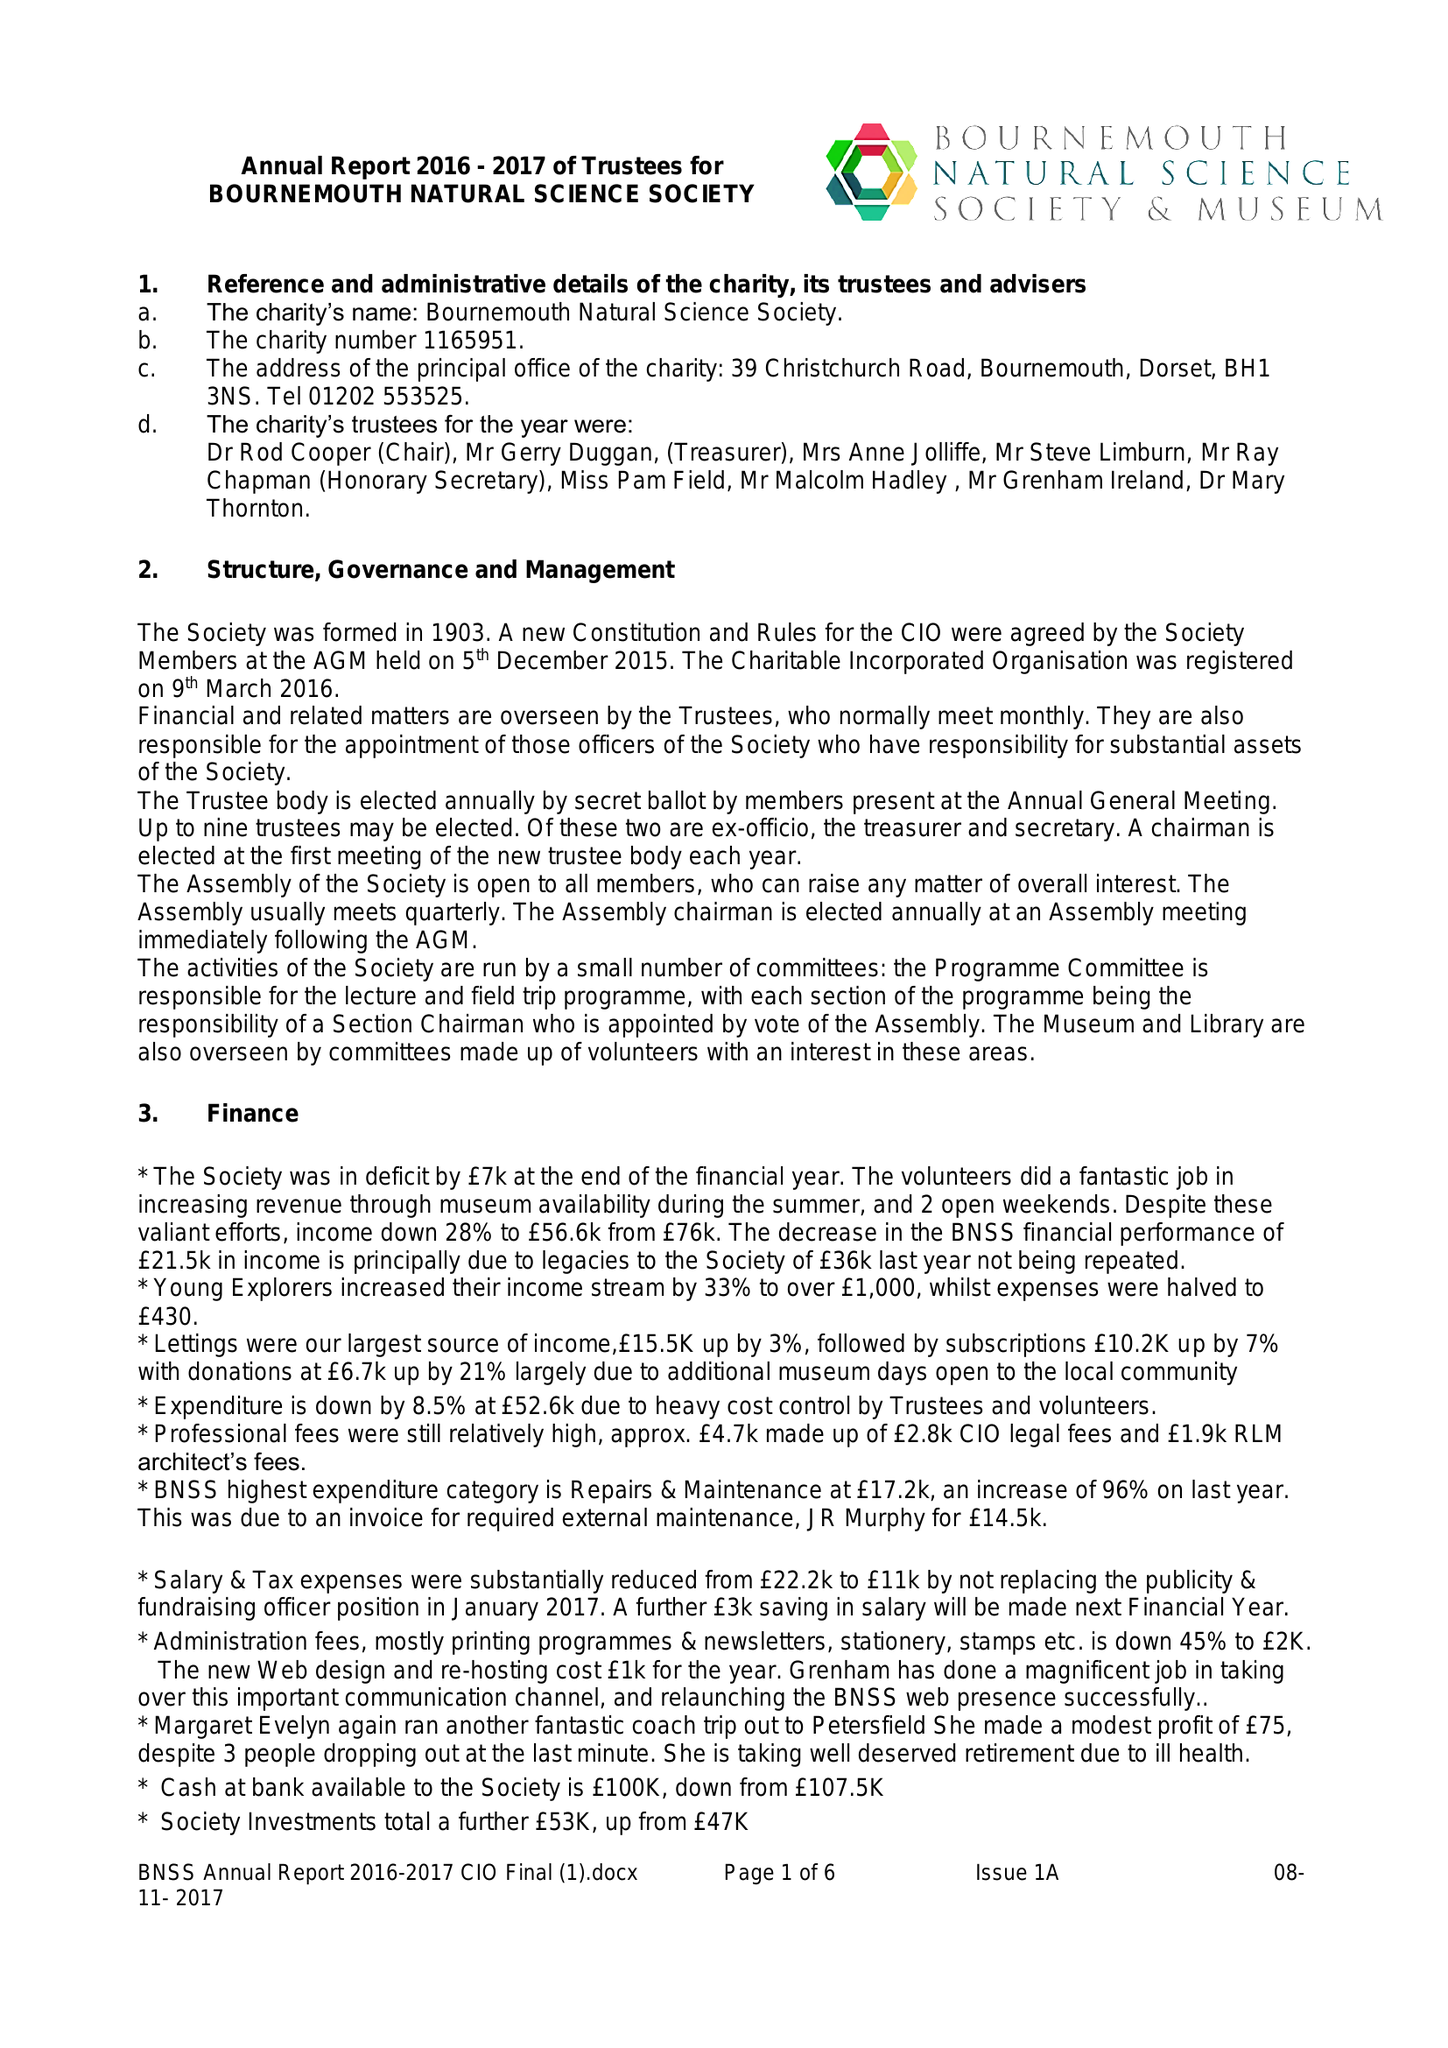What is the value for the address__postcode?
Answer the question using a single word or phrase. BH1 3NS 